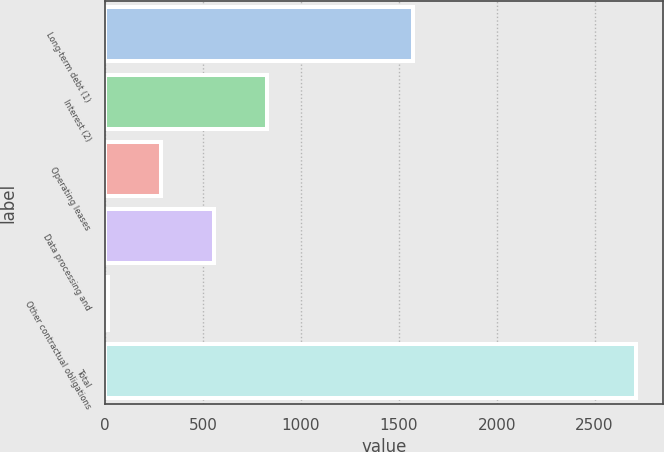Convert chart to OTSL. <chart><loc_0><loc_0><loc_500><loc_500><bar_chart><fcel>Long-term debt (1)<fcel>Interest (2)<fcel>Operating leases<fcel>Data processing and<fcel>Other contractual obligations<fcel>Total<nl><fcel>1573<fcel>825.5<fcel>286.5<fcel>556<fcel>17<fcel>2712<nl></chart> 